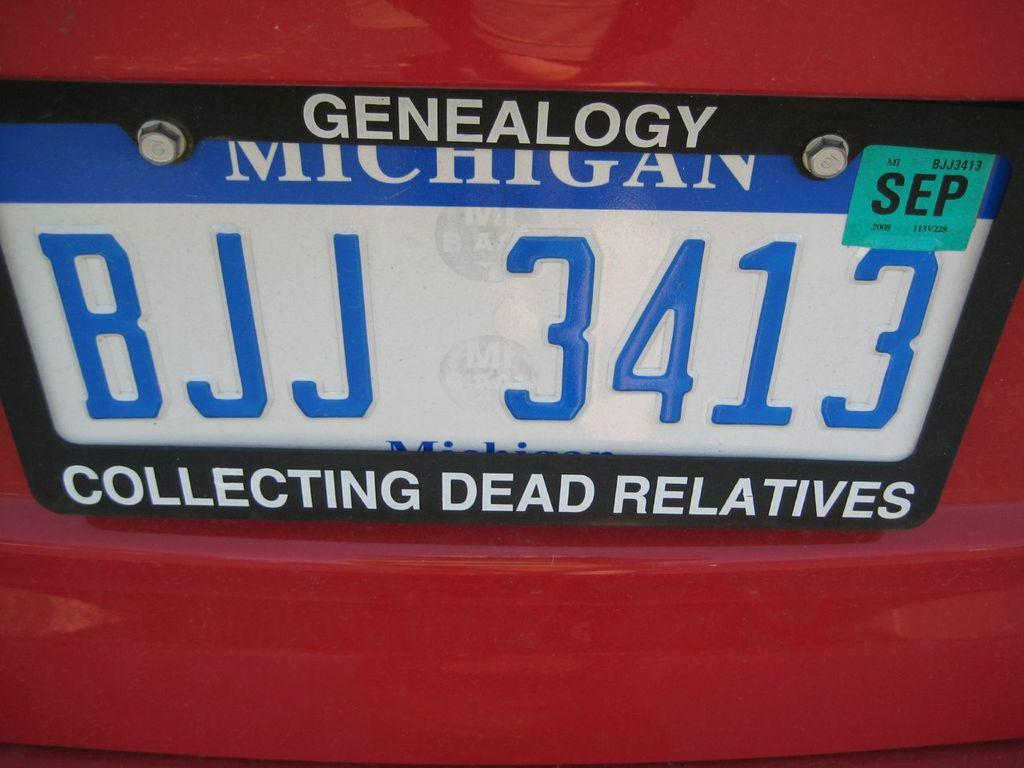What can be seen in the image related to vehicles? There is a number plate in the image. How many bears are visible in the image? There are no bears present in the image. What type of selection process is being depicted in the image? There is no selection process depicted in the image; it only features a number plate. 